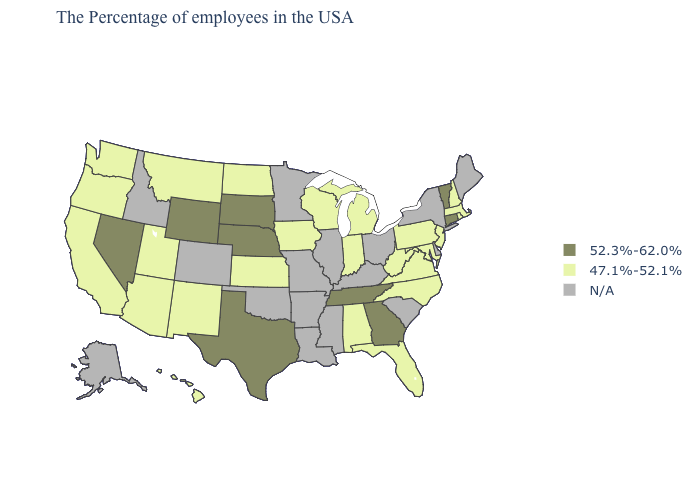Name the states that have a value in the range 47.1%-52.1%?
Quick response, please. Massachusetts, Rhode Island, New Hampshire, New Jersey, Maryland, Pennsylvania, Virginia, North Carolina, West Virginia, Florida, Michigan, Indiana, Alabama, Wisconsin, Iowa, Kansas, North Dakota, New Mexico, Utah, Montana, Arizona, California, Washington, Oregon, Hawaii. Does Montana have the lowest value in the West?
Be succinct. Yes. Does Nevada have the lowest value in the West?
Quick response, please. No. Name the states that have a value in the range 47.1%-52.1%?
Give a very brief answer. Massachusetts, Rhode Island, New Hampshire, New Jersey, Maryland, Pennsylvania, Virginia, North Carolina, West Virginia, Florida, Michigan, Indiana, Alabama, Wisconsin, Iowa, Kansas, North Dakota, New Mexico, Utah, Montana, Arizona, California, Washington, Oregon, Hawaii. What is the value of Michigan?
Answer briefly. 47.1%-52.1%. Does the map have missing data?
Keep it brief. Yes. Name the states that have a value in the range N/A?
Write a very short answer. Maine, New York, Delaware, South Carolina, Ohio, Kentucky, Illinois, Mississippi, Louisiana, Missouri, Arkansas, Minnesota, Oklahoma, Colorado, Idaho, Alaska. Does the map have missing data?
Give a very brief answer. Yes. What is the lowest value in the Northeast?
Answer briefly. 47.1%-52.1%. Name the states that have a value in the range N/A?
Quick response, please. Maine, New York, Delaware, South Carolina, Ohio, Kentucky, Illinois, Mississippi, Louisiana, Missouri, Arkansas, Minnesota, Oklahoma, Colorado, Idaho, Alaska. Does the first symbol in the legend represent the smallest category?
Short answer required. No. Name the states that have a value in the range 47.1%-52.1%?
Quick response, please. Massachusetts, Rhode Island, New Hampshire, New Jersey, Maryland, Pennsylvania, Virginia, North Carolina, West Virginia, Florida, Michigan, Indiana, Alabama, Wisconsin, Iowa, Kansas, North Dakota, New Mexico, Utah, Montana, Arizona, California, Washington, Oregon, Hawaii. What is the highest value in the Northeast ?
Be succinct. 52.3%-62.0%. What is the value of Virginia?
Keep it brief. 47.1%-52.1%. What is the lowest value in the Northeast?
Short answer required. 47.1%-52.1%. 